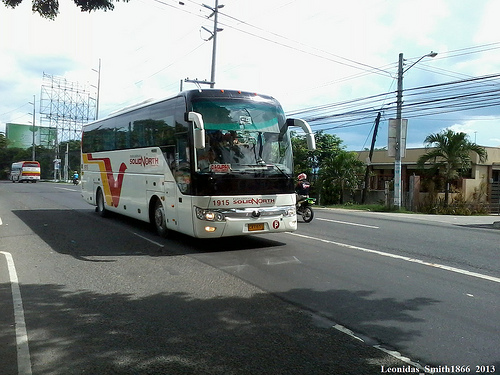What imaginative, surreal scene could you think of for this street? Imagine that this street transforms at dusk into a fantastical parade of glowing, magical creatures. Giant, luminescent butterflies flutter overhead, casting ethereal light down onto the road. The buses morph into ornate carriages pulled by mythical beasts, while sparkling stars descend to interact with the people. Trees along the street whisper ancient secrets in response to the glowing orbs floating around them. Exotic street performers dance with the rhythm of enchanting melodies, making the entire street feel like a scene from a dream. 